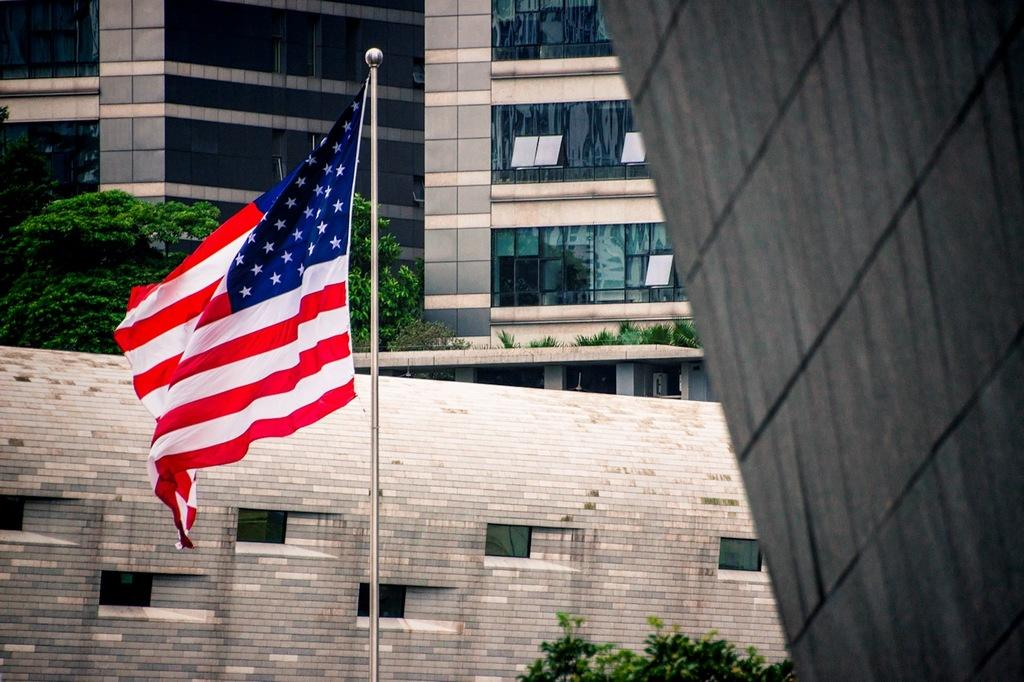What can be seen in the image that represents a country or symbol? There is a flag in the image. What colors are present on the flag? The flag has red, white, and blue colors. How is the flag displayed in the image? The flag is on a pole. What type of structures can be seen in the image? There are buildings in the image. What type of natural elements can be seen in the image? There are trees and plants in the image. What type of silk fabric is draped over the buildings in the image? There is no silk fabric present in the image; the buildings are not covered by any fabric. 